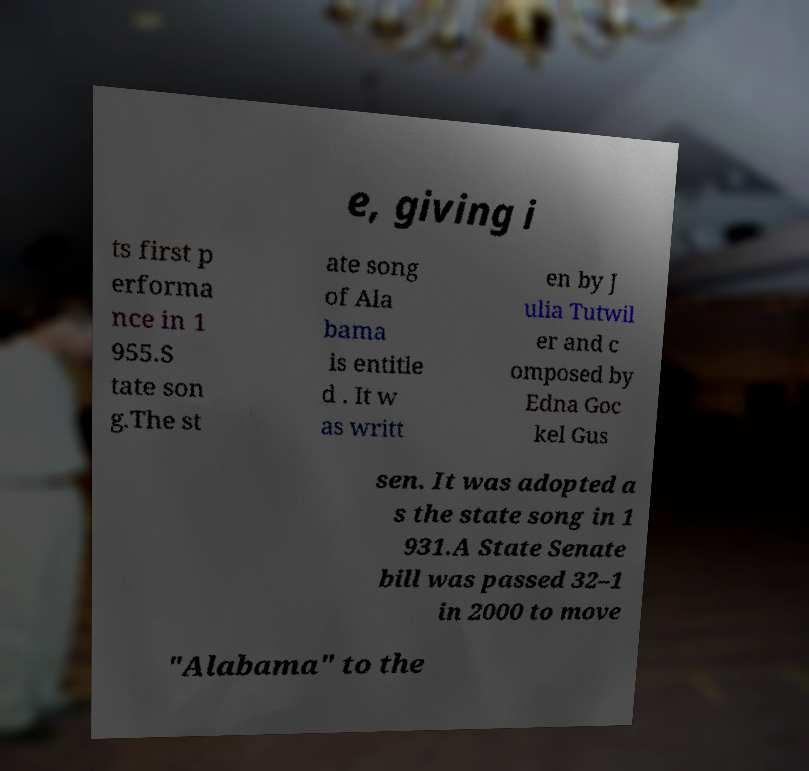Please identify and transcribe the text found in this image. e, giving i ts first p erforma nce in 1 955.S tate son g.The st ate song of Ala bama is entitle d . It w as writt en by J ulia Tutwil er and c omposed by Edna Goc kel Gus sen. It was adopted a s the state song in 1 931.A State Senate bill was passed 32–1 in 2000 to move "Alabama" to the 